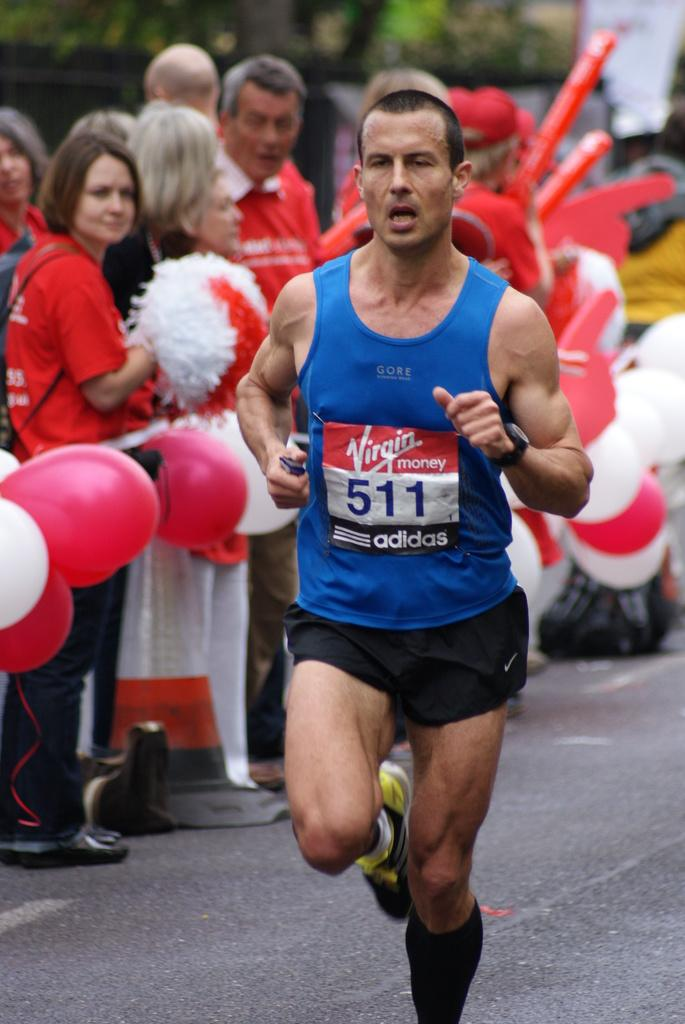<image>
Offer a succinct explanation of the picture presented. runner number 511 wearing blue and black going past crowd wearing red 